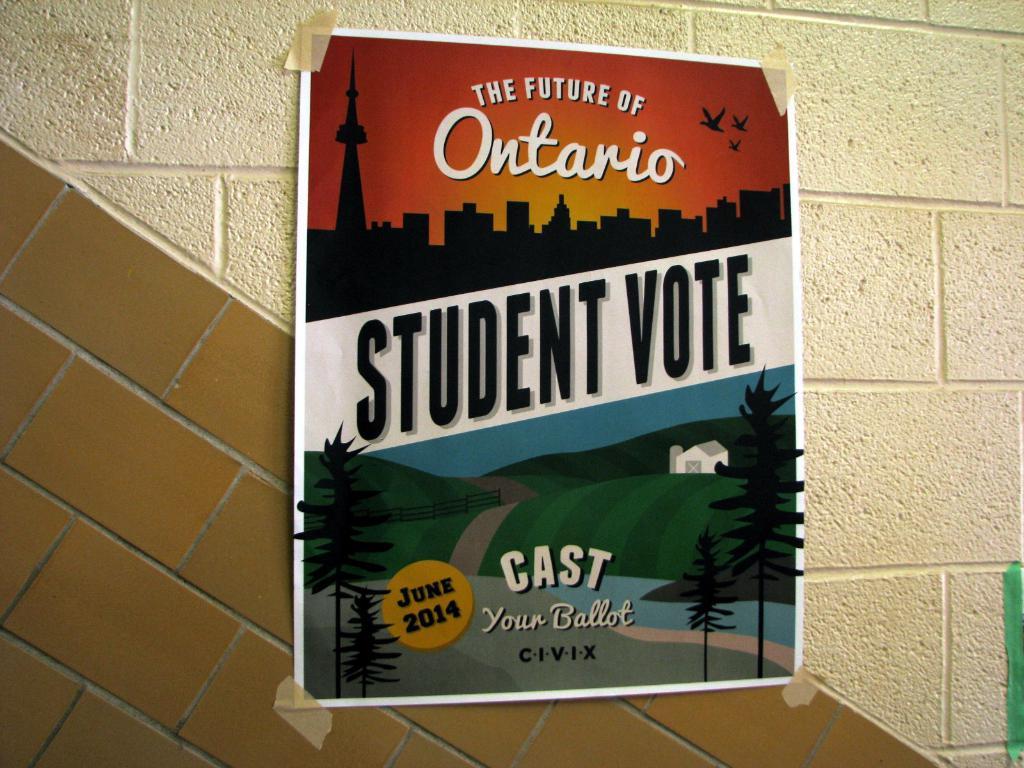What canadian city is on the poster?
Provide a short and direct response. Ontario. Is this talking about a student vote?
Keep it short and to the point. Yes. 